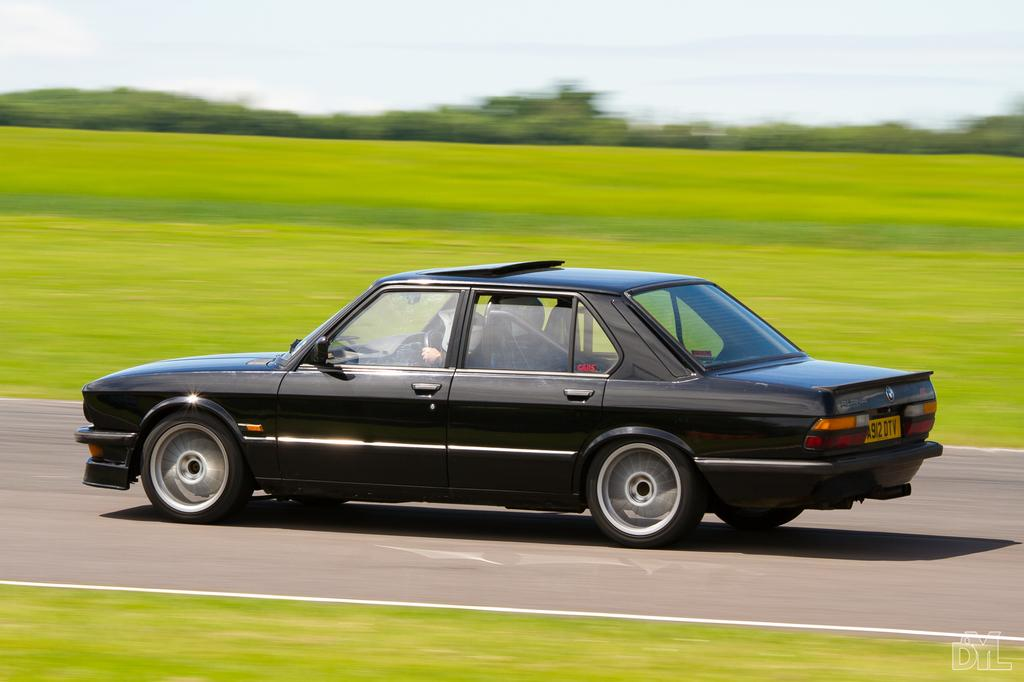What type of vehicle is in the image? There is a black car in the image. Where is the car located? The car is on a road. What can be seen on either side of the road? Grassland is visible on either side of the road. What is in the background of the image? There are trees in the background of the image. What part of the natural environment is visible in the image? The sky is visible in the image. How does the car show signs of growth in the image? The car does not show signs of growth in the image; it is a stationary object. 